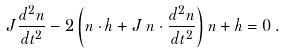<formula> <loc_0><loc_0><loc_500><loc_500>J \frac { d ^ { 2 } n } { d t ^ { 2 } } - 2 \left ( n \cdot h + J \, n \cdot \frac { d ^ { 2 } n } { d t ^ { 2 } } \right ) n + h = 0 \, .</formula> 